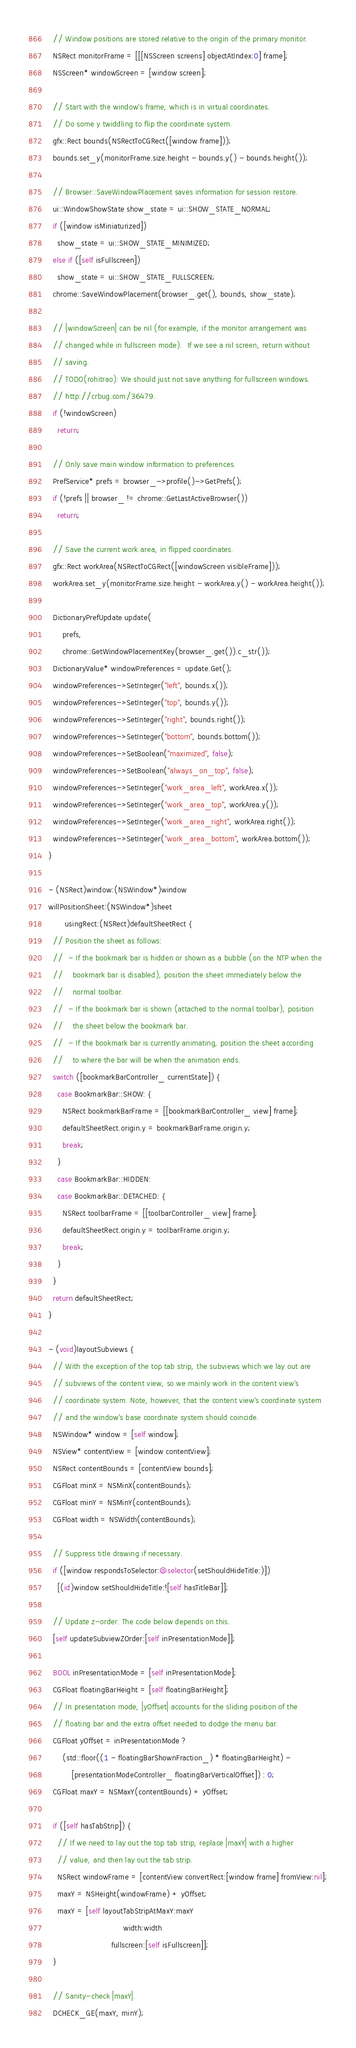Convert code to text. <code><loc_0><loc_0><loc_500><loc_500><_ObjectiveC_>
  // Window positions are stored relative to the origin of the primary monitor.
  NSRect monitorFrame = [[[NSScreen screens] objectAtIndex:0] frame];
  NSScreen* windowScreen = [window screen];

  // Start with the window's frame, which is in virtual coordinates.
  // Do some y twiddling to flip the coordinate system.
  gfx::Rect bounds(NSRectToCGRect([window frame]));
  bounds.set_y(monitorFrame.size.height - bounds.y() - bounds.height());

  // Browser::SaveWindowPlacement saves information for session restore.
  ui::WindowShowState show_state = ui::SHOW_STATE_NORMAL;
  if ([window isMiniaturized])
    show_state = ui::SHOW_STATE_MINIMIZED;
  else if ([self isFullscreen])
    show_state = ui::SHOW_STATE_FULLSCREEN;
  chrome::SaveWindowPlacement(browser_.get(), bounds, show_state);

  // |windowScreen| can be nil (for example, if the monitor arrangement was
  // changed while in fullscreen mode).  If we see a nil screen, return without
  // saving.
  // TODO(rohitrao): We should just not save anything for fullscreen windows.
  // http://crbug.com/36479.
  if (!windowScreen)
    return;

  // Only save main window information to preferences.
  PrefService* prefs = browser_->profile()->GetPrefs();
  if (!prefs || browser_ != chrome::GetLastActiveBrowser())
    return;

  // Save the current work area, in flipped coordinates.
  gfx::Rect workArea(NSRectToCGRect([windowScreen visibleFrame]));
  workArea.set_y(monitorFrame.size.height - workArea.y() - workArea.height());

  DictionaryPrefUpdate update(
      prefs,
      chrome::GetWindowPlacementKey(browser_.get()).c_str());
  DictionaryValue* windowPreferences = update.Get();
  windowPreferences->SetInteger("left", bounds.x());
  windowPreferences->SetInteger("top", bounds.y());
  windowPreferences->SetInteger("right", bounds.right());
  windowPreferences->SetInteger("bottom", bounds.bottom());
  windowPreferences->SetBoolean("maximized", false);
  windowPreferences->SetBoolean("always_on_top", false);
  windowPreferences->SetInteger("work_area_left", workArea.x());
  windowPreferences->SetInteger("work_area_top", workArea.y());
  windowPreferences->SetInteger("work_area_right", workArea.right());
  windowPreferences->SetInteger("work_area_bottom", workArea.bottom());
}

- (NSRect)window:(NSWindow*)window
willPositionSheet:(NSWindow*)sheet
       usingRect:(NSRect)defaultSheetRect {
  // Position the sheet as follows:
  //  - If the bookmark bar is hidden or shown as a bubble (on the NTP when the
  //    bookmark bar is disabled), position the sheet immediately below the
  //    normal toolbar.
  //  - If the bookmark bar is shown (attached to the normal toolbar), position
  //    the sheet below the bookmark bar.
  //  - If the bookmark bar is currently animating, position the sheet according
  //    to where the bar will be when the animation ends.
  switch ([bookmarkBarController_ currentState]) {
    case BookmarkBar::SHOW: {
      NSRect bookmarkBarFrame = [[bookmarkBarController_ view] frame];
      defaultSheetRect.origin.y = bookmarkBarFrame.origin.y;
      break;
    }
    case BookmarkBar::HIDDEN:
    case BookmarkBar::DETACHED: {
      NSRect toolbarFrame = [[toolbarController_ view] frame];
      defaultSheetRect.origin.y = toolbarFrame.origin.y;
      break;
    }
  }
  return defaultSheetRect;
}

- (void)layoutSubviews {
  // With the exception of the top tab strip, the subviews which we lay out are
  // subviews of the content view, so we mainly work in the content view's
  // coordinate system. Note, however, that the content view's coordinate system
  // and the window's base coordinate system should coincide.
  NSWindow* window = [self window];
  NSView* contentView = [window contentView];
  NSRect contentBounds = [contentView bounds];
  CGFloat minX = NSMinX(contentBounds);
  CGFloat minY = NSMinY(contentBounds);
  CGFloat width = NSWidth(contentBounds);

  // Suppress title drawing if necessary.
  if ([window respondsToSelector:@selector(setShouldHideTitle:)])
    [(id)window setShouldHideTitle:![self hasTitleBar]];

  // Update z-order. The code below depends on this.
  [self updateSubviewZOrder:[self inPresentationMode]];

  BOOL inPresentationMode = [self inPresentationMode];
  CGFloat floatingBarHeight = [self floatingBarHeight];
  // In presentation mode, |yOffset| accounts for the sliding position of the
  // floating bar and the extra offset needed to dodge the menu bar.
  CGFloat yOffset = inPresentationMode ?
      (std::floor((1 - floatingBarShownFraction_) * floatingBarHeight) -
          [presentationModeController_ floatingBarVerticalOffset]) : 0;
  CGFloat maxY = NSMaxY(contentBounds) + yOffset;

  if ([self hasTabStrip]) {
    // If we need to lay out the top tab strip, replace |maxY| with a higher
    // value, and then lay out the tab strip.
    NSRect windowFrame = [contentView convertRect:[window frame] fromView:nil];
    maxY = NSHeight(windowFrame) + yOffset;
    maxY = [self layoutTabStripAtMaxY:maxY
                                width:width
                           fullscreen:[self isFullscreen]];
  }

  // Sanity-check |maxY|.
  DCHECK_GE(maxY, minY);</code> 